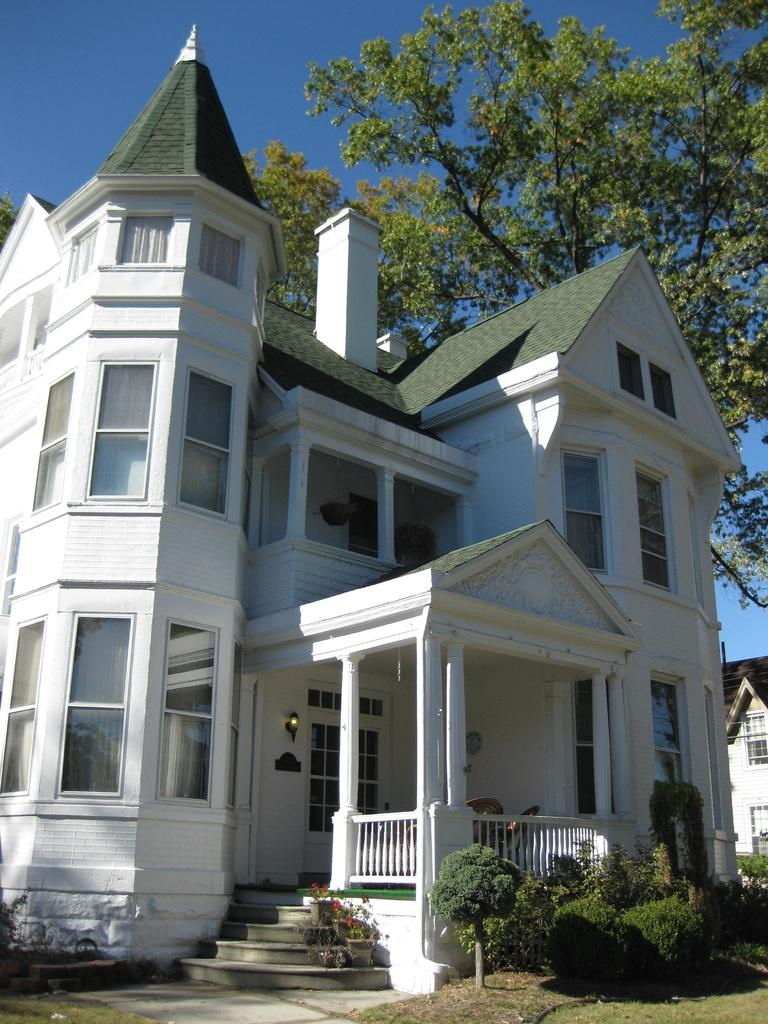What type of structures can be seen in the image? There are buildings in the image. What can be seen beneath the buildings and objects in the image? The ground is visible in the image. What is present on the ground in the image? There are objects on the ground in the image. What type of vegetation is visible in the image? There is grass, plants, and trees in the image. What part of the natural environment is visible in the image? The sky is visible in the image. Are there any architectural features in the image? Yes, there are stairs in the image. What type of muscle is visible in the image? There is no muscle visible in the image; it features buildings, ground, objects, grass, plants, trees, and stairs. What type of agreement is being made in the image? There is no agreement being made in the image; it is a scene with buildings, ground, objects, grass, plants, trees, and stairs. 